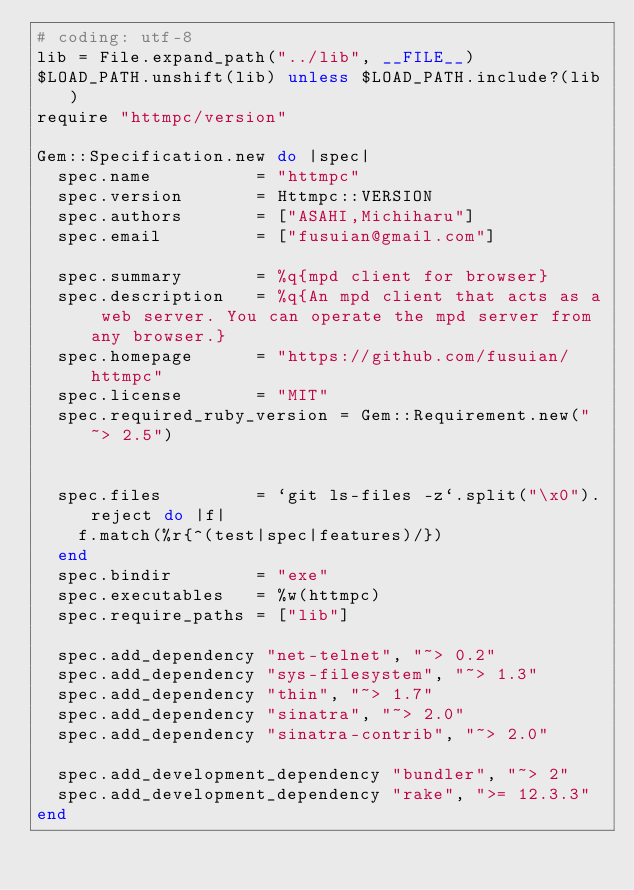<code> <loc_0><loc_0><loc_500><loc_500><_Ruby_># coding: utf-8
lib = File.expand_path("../lib", __FILE__)
$LOAD_PATH.unshift(lib) unless $LOAD_PATH.include?(lib)
require "httmpc/version"

Gem::Specification.new do |spec|
  spec.name          = "httmpc"
  spec.version       = Httmpc::VERSION
  spec.authors       = ["ASAHI,Michiharu"]
  spec.email         = ["fusuian@gmail.com"]

  spec.summary       = %q{mpd client for browser}
  spec.description   = %q{An mpd client that acts as a web server. You can operate the mpd server from any browser.}
  spec.homepage      = "https://github.com/fusuian/httmpc"
  spec.license       = "MIT"
  spec.required_ruby_version = Gem::Requirement.new("~> 2.5")


  spec.files         = `git ls-files -z`.split("\x0").reject do |f|
    f.match(%r{^(test|spec|features)/})
  end
  spec.bindir        = "exe"
  spec.executables   = %w(httmpc)
  spec.require_paths = ["lib"]

  spec.add_dependency "net-telnet", "~> 0.2"
  spec.add_dependency "sys-filesystem", "~> 1.3"
  spec.add_dependency "thin", "~> 1.7"
  spec.add_dependency "sinatra", "~> 2.0"
  spec.add_dependency "sinatra-contrib", "~> 2.0"

  spec.add_development_dependency "bundler", "~> 2"
  spec.add_development_dependency "rake", ">= 12.3.3"
end
</code> 